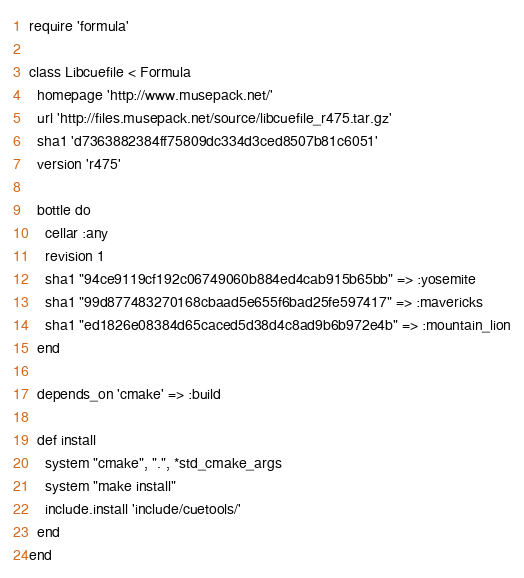Convert code to text. <code><loc_0><loc_0><loc_500><loc_500><_Ruby_>require 'formula'

class Libcuefile < Formula
  homepage 'http://www.musepack.net/'
  url 'http://files.musepack.net/source/libcuefile_r475.tar.gz'
  sha1 'd7363882384ff75809dc334d3ced8507b81c6051'
  version 'r475'

  bottle do
    cellar :any
    revision 1
    sha1 "94ce9119cf192c06749060b884ed4cab915b65bb" => :yosemite
    sha1 "99d877483270168cbaad5e655f6bad25fe597417" => :mavericks
    sha1 "ed1826e08384d65caced5d38d4c8ad9b6b972e4b" => :mountain_lion
  end

  depends_on 'cmake' => :build

  def install
    system "cmake", ".", *std_cmake_args
    system "make install"
    include.install 'include/cuetools/'
  end
end
</code> 